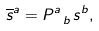<formula> <loc_0><loc_0><loc_500><loc_500>\overline { s } ^ { a } = P ^ { a } _ { \ b } \, s ^ { b } ,</formula> 